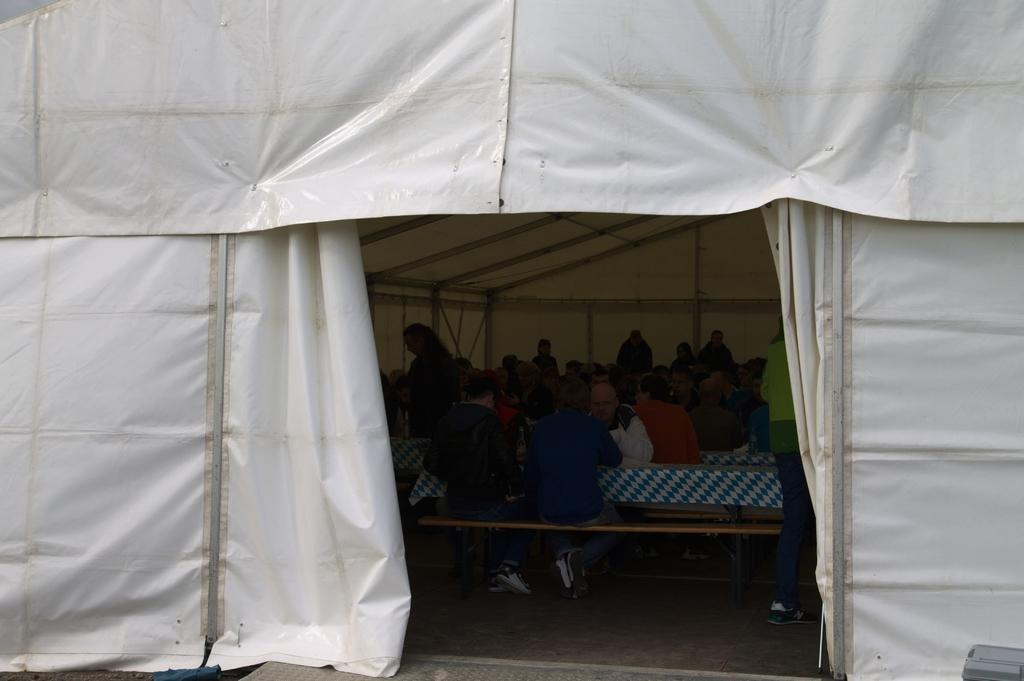What are the people in the image doing? The persons in the image are sitting on the benches. Where are the benches located in the image? The benches are in the middle of the image. What structure can be seen in the image besides the benches? There is a tent in the image. What is the color of the tent? The tent is white in color. Where is the tent located in the image? The tent is located at the top of the image. How many shelves are visible in the image? There are no shelves present in the image. What type of feather can be seen on the tent in the image? There are no feathers present on the tent in the image. 